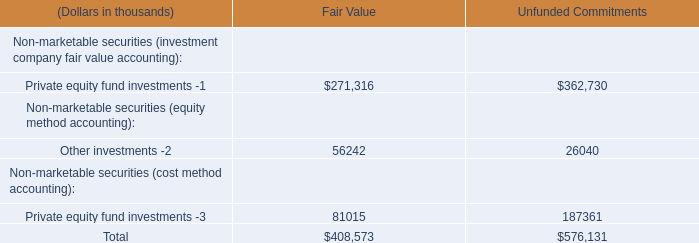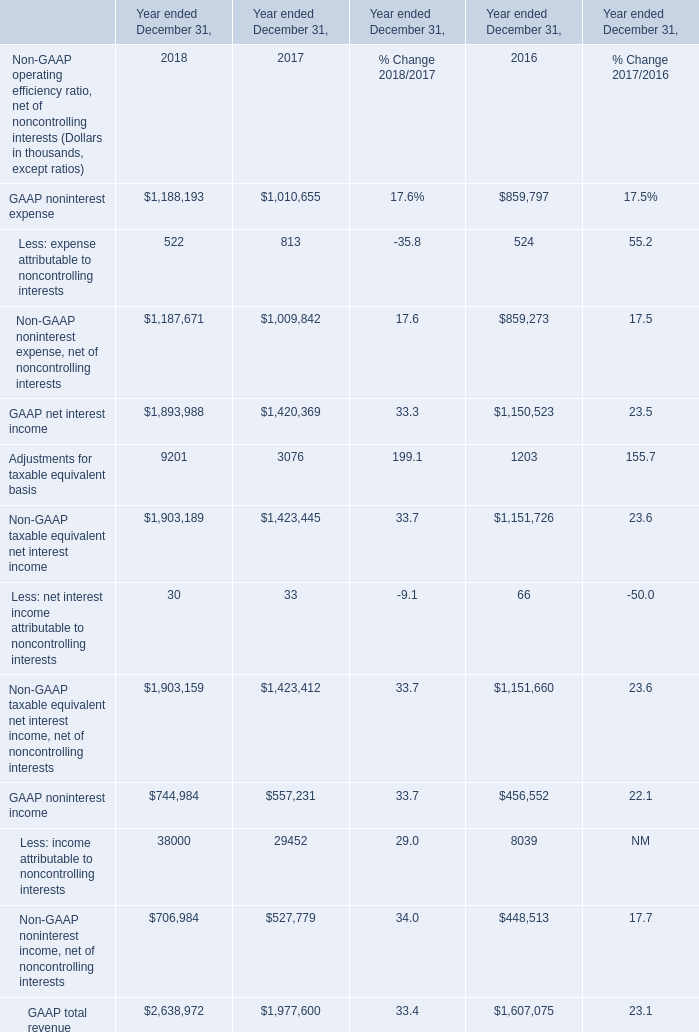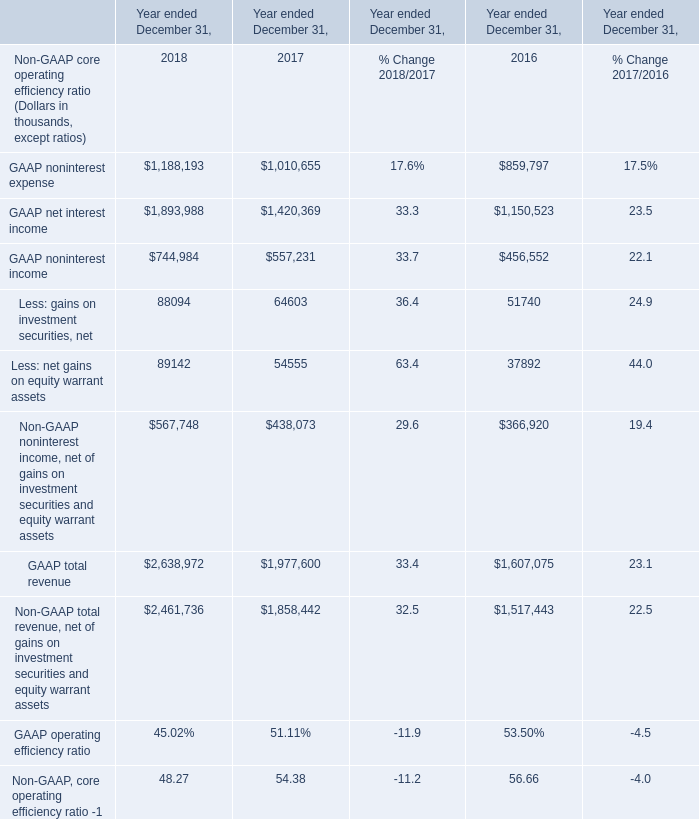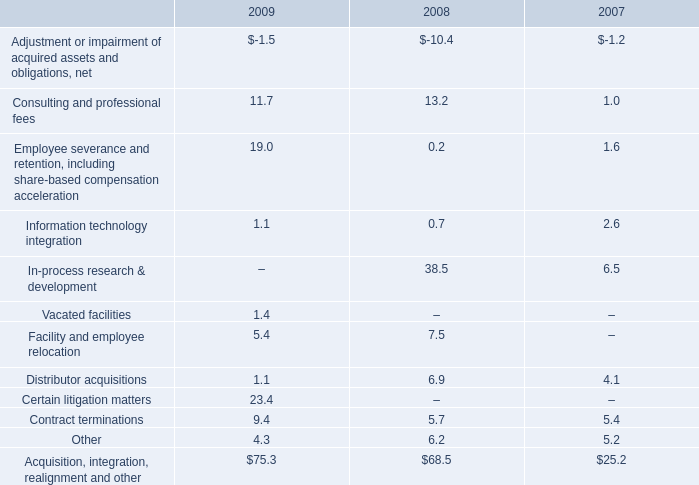What is the growing rate of Less: net interest income attributable to noncontrolling interests in the year with the most GAAP noninterest expense? 
Computations: ((30 - 33) / 30)
Answer: -0.1. 